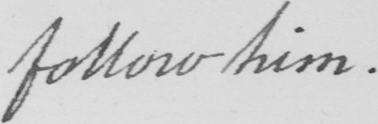Can you read and transcribe this handwriting? follow him .  _   _   _   _   _   _ 